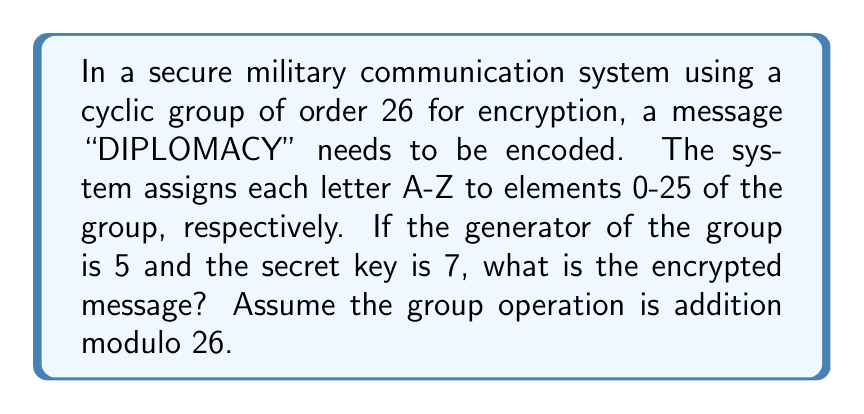Could you help me with this problem? To solve this problem, we'll follow these steps:

1) First, we need to understand the encryption process:
   - Each letter is assigned a number from 0 to 25 (A=0, B=1, ..., Z=25)
   - The encryption formula is: $E(x) = (gx + k) \mod 26$
   where $g$ is the generator (5 in this case), $k$ is the secret key (7 in this case), and $x$ is the numerical value of each letter.

2) Let's convert "DIPLOMACY" to numbers:
   D = 3, I = 8, P = 15, L = 11, O = 14, M = 12, A = 0, C = 2, Y = 24

3) Now, we'll apply the encryption formula to each number:

   For D (3): $E(3) = (5 \cdot 3 + 7) \mod 26 = 22 \mod 26 = 22$
   For I (8): $E(8) = (5 \cdot 8 + 7) \mod 26 = 47 \mod 26 = 21$
   For P (15): $E(15) = (5 \cdot 15 + 7) \mod 26 = 82 \mod 26 = 4$
   For L (11): $E(11) = (5 \cdot 11 + 7) \mod 26 = 62 \mod 26 = 10$
   For O (14): $E(14) = (5 \cdot 14 + 7) \mod 26 = 77 \mod 26 = 25$
   For M (12): $E(12) = (5 \cdot 12 + 7) \mod 26 = 67 \mod 26 = 15$
   For A (0): $E(0) = (5 \cdot 0 + 7) \mod 26 = 7 \mod 26 = 7$
   For C (2): $E(2) = (5 \cdot 2 + 7) \mod 26 = 17 \mod 26 = 17$
   For Y (24): $E(24) = (5 \cdot 24 + 7) \mod 26 = 127 \mod 26 = 23$

4) Finally, we convert these numbers back to letters:
   22 = W, 21 = V, 4 = E, 10 = K, 25 = Z, 15 = P, 7 = H, 17 = R, 23 = X
Answer: The encrypted message is WVEKZPHRX. 